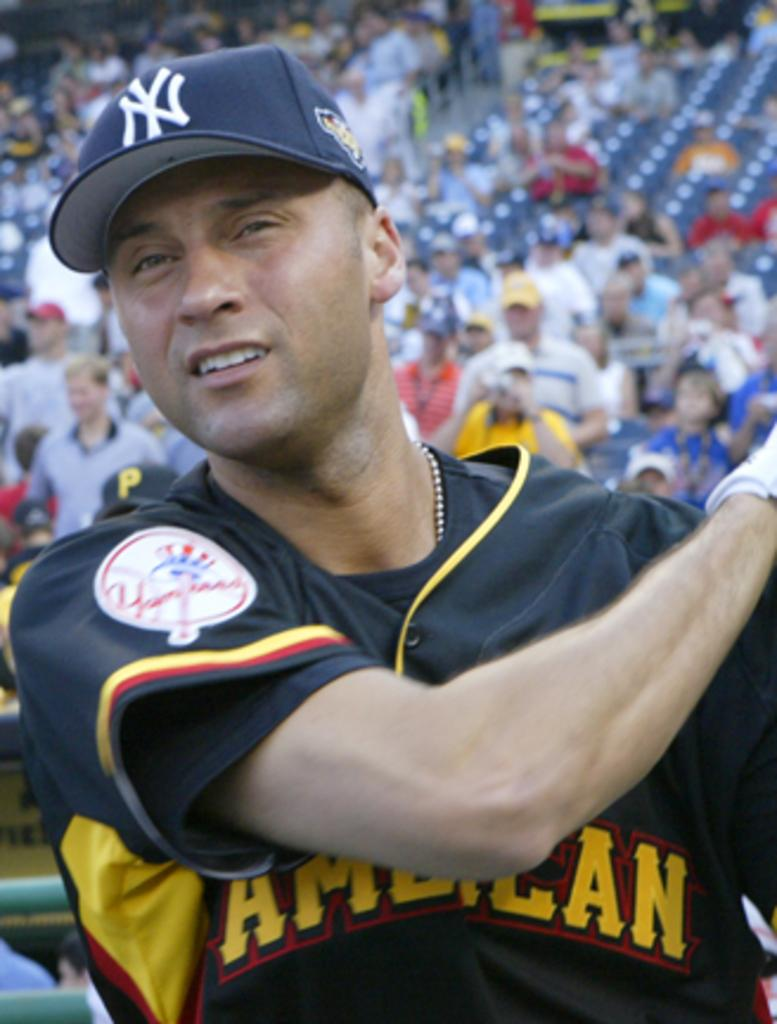<image>
Relay a brief, clear account of the picture shown. A New York Yankees baseball player wearing a jersey that says American. 